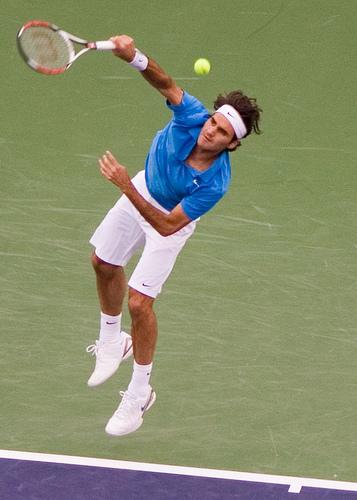Is the player wearing a headband?
Concise answer only. Yes. Is the man jumping or standing?
Give a very brief answer. Jumping. Did the man hit the ball?
Short answer required. Yes. 